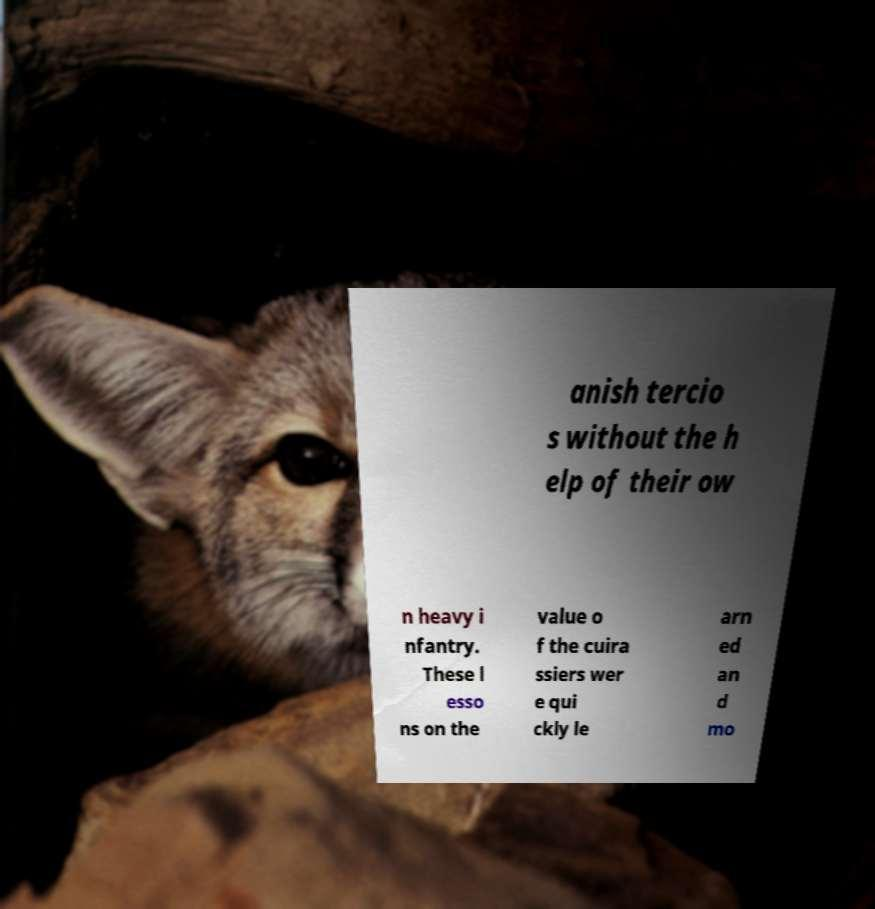Can you read and provide the text displayed in the image?This photo seems to have some interesting text. Can you extract and type it out for me? anish tercio s without the h elp of their ow n heavy i nfantry. These l esso ns on the value o f the cuira ssiers wer e qui ckly le arn ed an d mo 